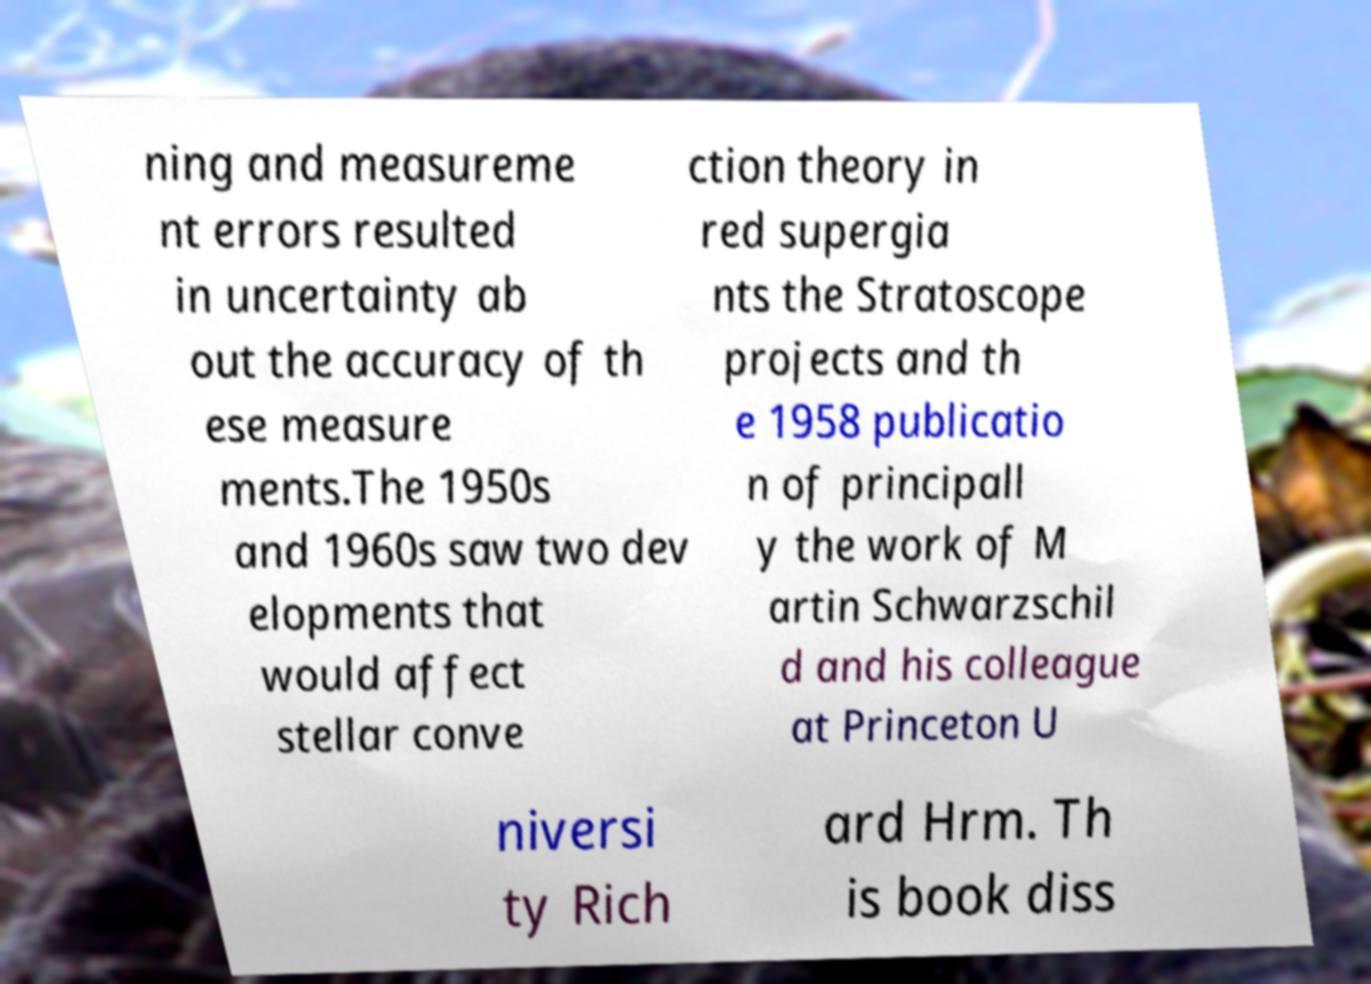Could you assist in decoding the text presented in this image and type it out clearly? ning and measureme nt errors resulted in uncertainty ab out the accuracy of th ese measure ments.The 1950s and 1960s saw two dev elopments that would affect stellar conve ction theory in red supergia nts the Stratoscope projects and th e 1958 publicatio n of principall y the work of M artin Schwarzschil d and his colleague at Princeton U niversi ty Rich ard Hrm. Th is book diss 